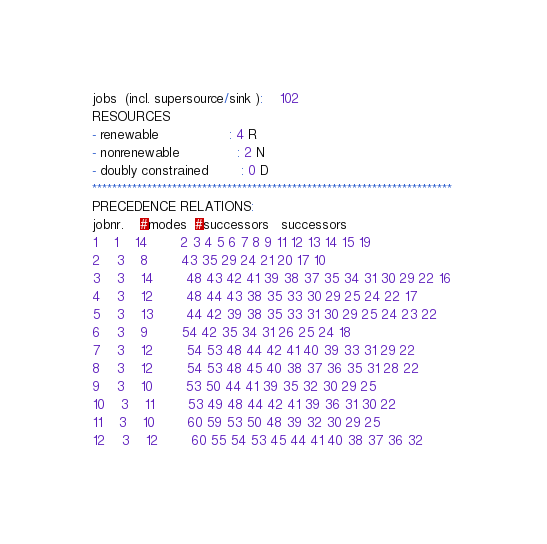<code> <loc_0><loc_0><loc_500><loc_500><_ObjectiveC_>jobs  (incl. supersource/sink ):	102
RESOURCES
- renewable                 : 4 R
- nonrenewable              : 2 N
- doubly constrained        : 0 D
************************************************************************
PRECEDENCE RELATIONS:
jobnr.    #modes  #successors   successors
1	1	14		2 3 4 5 6 7 8 9 11 12 13 14 15 19 
2	3	8		43 35 29 24 21 20 17 10 
3	3	14		48 43 42 41 39 38 37 35 34 31 30 29 22 16 
4	3	12		48 44 43 38 35 33 30 29 25 24 22 17 
5	3	13		44 42 39 38 35 33 31 30 29 25 24 23 22 
6	3	9		54 42 35 34 31 26 25 24 18 
7	3	12		54 53 48 44 42 41 40 39 33 31 29 22 
8	3	12		54 53 48 45 40 38 37 36 35 31 28 22 
9	3	10		53 50 44 41 39 35 32 30 29 25 
10	3	11		53 49 48 44 42 41 39 36 31 30 22 
11	3	10		60 59 53 50 48 39 32 30 29 25 
12	3	12		60 55 54 53 45 44 41 40 38 37 36 32 </code> 